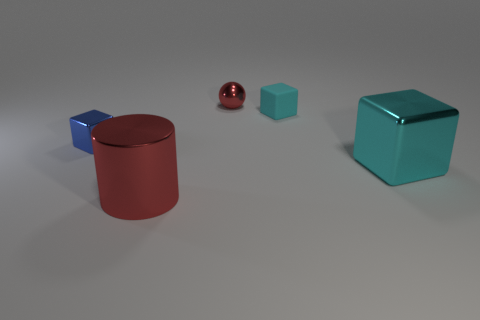Is there anything else that has the same material as the small cyan thing?
Give a very brief answer. No. There is another block that is the same color as the large block; what is it made of?
Offer a terse response. Rubber. What is the color of the large cylinder that is the same material as the red ball?
Give a very brief answer. Red. What number of large objects are red cubes or red spheres?
Your response must be concise. 0. What number of metallic objects are left of the matte block?
Your answer should be compact. 3. There is a matte object that is the same shape as the blue metal thing; what is its color?
Offer a terse response. Cyan. How many rubber things are either cylinders or cyan blocks?
Provide a short and direct response. 1. There is a cyan object behind the cube to the left of the ball; is there a big object that is on the left side of it?
Give a very brief answer. Yes. What color is the tiny sphere?
Make the answer very short. Red. There is a cyan thing that is behind the big cyan metal cube; is its shape the same as the cyan metallic object?
Give a very brief answer. Yes. 